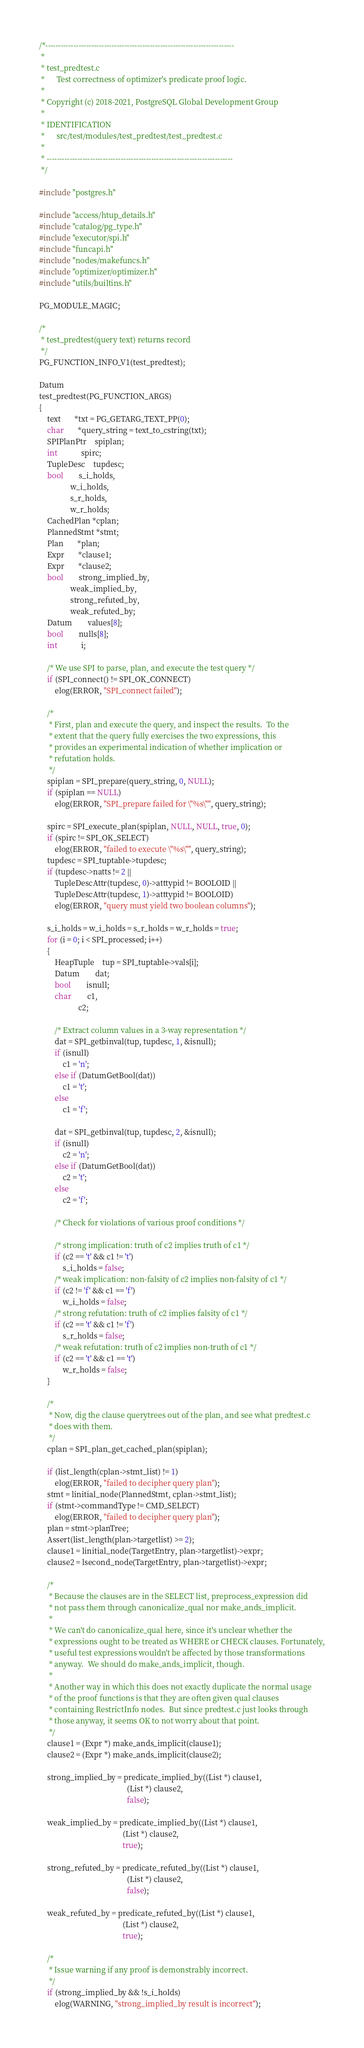Convert code to text. <code><loc_0><loc_0><loc_500><loc_500><_C_>/*--------------------------------------------------------------------------
 *
 * test_predtest.c
 *		Test correctness of optimizer's predicate proof logic.
 *
 * Copyright (c) 2018-2021, PostgreSQL Global Development Group
 *
 * IDENTIFICATION
 *		src/test/modules/test_predtest/test_predtest.c
 *
 * -------------------------------------------------------------------------
 */

#include "postgres.h"

#include "access/htup_details.h"
#include "catalog/pg_type.h"
#include "executor/spi.h"
#include "funcapi.h"
#include "nodes/makefuncs.h"
#include "optimizer/optimizer.h"
#include "utils/builtins.h"

PG_MODULE_MAGIC;

/*
 * test_predtest(query text) returns record
 */
PG_FUNCTION_INFO_V1(test_predtest);

Datum
test_predtest(PG_FUNCTION_ARGS)
{
	text	   *txt = PG_GETARG_TEXT_PP(0);
	char	   *query_string = text_to_cstring(txt);
	SPIPlanPtr	spiplan;
	int			spirc;
	TupleDesc	tupdesc;
	bool		s_i_holds,
				w_i_holds,
				s_r_holds,
				w_r_holds;
	CachedPlan *cplan;
	PlannedStmt *stmt;
	Plan	   *plan;
	Expr	   *clause1;
	Expr	   *clause2;
	bool		strong_implied_by,
				weak_implied_by,
				strong_refuted_by,
				weak_refuted_by;
	Datum		values[8];
	bool		nulls[8];
	int			i;

	/* We use SPI to parse, plan, and execute the test query */
	if (SPI_connect() != SPI_OK_CONNECT)
		elog(ERROR, "SPI_connect failed");

	/*
	 * First, plan and execute the query, and inspect the results.  To the
	 * extent that the query fully exercises the two expressions, this
	 * provides an experimental indication of whether implication or
	 * refutation holds.
	 */
	spiplan = SPI_prepare(query_string, 0, NULL);
	if (spiplan == NULL)
		elog(ERROR, "SPI_prepare failed for \"%s\"", query_string);

	spirc = SPI_execute_plan(spiplan, NULL, NULL, true, 0);
	if (spirc != SPI_OK_SELECT)
		elog(ERROR, "failed to execute \"%s\"", query_string);
	tupdesc = SPI_tuptable->tupdesc;
	if (tupdesc->natts != 2 ||
		TupleDescAttr(tupdesc, 0)->atttypid != BOOLOID ||
		TupleDescAttr(tupdesc, 1)->atttypid != BOOLOID)
		elog(ERROR, "query must yield two boolean columns");

	s_i_holds = w_i_holds = s_r_holds = w_r_holds = true;
	for (i = 0; i < SPI_processed; i++)
	{
		HeapTuple	tup = SPI_tuptable->vals[i];
		Datum		dat;
		bool		isnull;
		char		c1,
					c2;

		/* Extract column values in a 3-way representation */
		dat = SPI_getbinval(tup, tupdesc, 1, &isnull);
		if (isnull)
			c1 = 'n';
		else if (DatumGetBool(dat))
			c1 = 't';
		else
			c1 = 'f';

		dat = SPI_getbinval(tup, tupdesc, 2, &isnull);
		if (isnull)
			c2 = 'n';
		else if (DatumGetBool(dat))
			c2 = 't';
		else
			c2 = 'f';

		/* Check for violations of various proof conditions */

		/* strong implication: truth of c2 implies truth of c1 */
		if (c2 == 't' && c1 != 't')
			s_i_holds = false;
		/* weak implication: non-falsity of c2 implies non-falsity of c1 */
		if (c2 != 'f' && c1 == 'f')
			w_i_holds = false;
		/* strong refutation: truth of c2 implies falsity of c1 */
		if (c2 == 't' && c1 != 'f')
			s_r_holds = false;
		/* weak refutation: truth of c2 implies non-truth of c1 */
		if (c2 == 't' && c1 == 't')
			w_r_holds = false;
	}

	/*
	 * Now, dig the clause querytrees out of the plan, and see what predtest.c
	 * does with them.
	 */
	cplan = SPI_plan_get_cached_plan(spiplan);

	if (list_length(cplan->stmt_list) != 1)
		elog(ERROR, "failed to decipher query plan");
	stmt = linitial_node(PlannedStmt, cplan->stmt_list);
	if (stmt->commandType != CMD_SELECT)
		elog(ERROR, "failed to decipher query plan");
	plan = stmt->planTree;
	Assert(list_length(plan->targetlist) >= 2);
	clause1 = linitial_node(TargetEntry, plan->targetlist)->expr;
	clause2 = lsecond_node(TargetEntry, plan->targetlist)->expr;

	/*
	 * Because the clauses are in the SELECT list, preprocess_expression did
	 * not pass them through canonicalize_qual nor make_ands_implicit.
	 *
	 * We can't do canonicalize_qual here, since it's unclear whether the
	 * expressions ought to be treated as WHERE or CHECK clauses. Fortunately,
	 * useful test expressions wouldn't be affected by those transformations
	 * anyway.  We should do make_ands_implicit, though.
	 *
	 * Another way in which this does not exactly duplicate the normal usage
	 * of the proof functions is that they are often given qual clauses
	 * containing RestrictInfo nodes.  But since predtest.c just looks through
	 * those anyway, it seems OK to not worry about that point.
	 */
	clause1 = (Expr *) make_ands_implicit(clause1);
	clause2 = (Expr *) make_ands_implicit(clause2);

	strong_implied_by = predicate_implied_by((List *) clause1,
											 (List *) clause2,
											 false);

	weak_implied_by = predicate_implied_by((List *) clause1,
										   (List *) clause2,
										   true);

	strong_refuted_by = predicate_refuted_by((List *) clause1,
											 (List *) clause2,
											 false);

	weak_refuted_by = predicate_refuted_by((List *) clause1,
										   (List *) clause2,
										   true);

	/*
	 * Issue warning if any proof is demonstrably incorrect.
	 */
	if (strong_implied_by && !s_i_holds)
		elog(WARNING, "strong_implied_by result is incorrect");</code> 